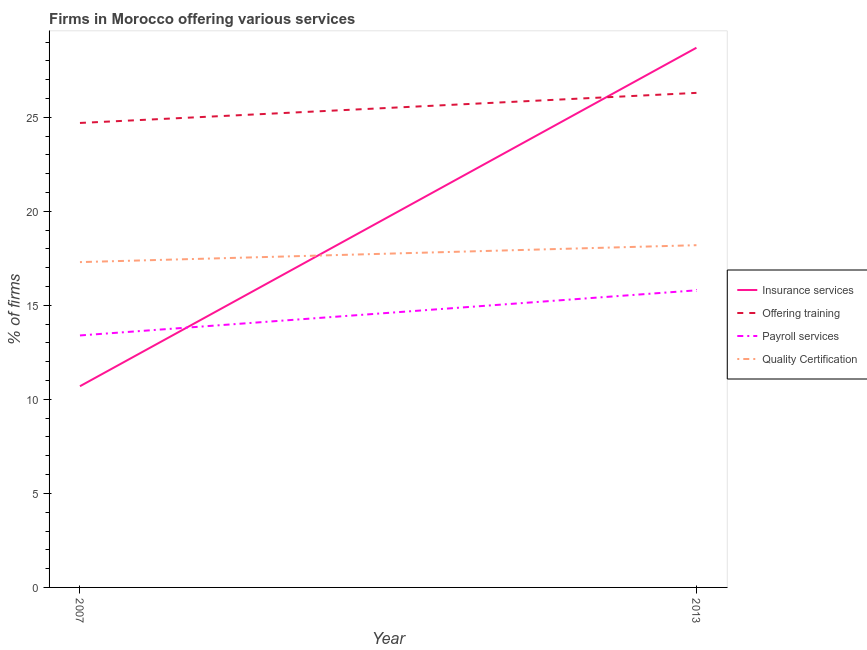How many different coloured lines are there?
Give a very brief answer. 4. What is the percentage of firms offering quality certification in 2013?
Ensure brevity in your answer.  18.2. Across all years, what is the maximum percentage of firms offering training?
Offer a very short reply. 26.3. In which year was the percentage of firms offering insurance services maximum?
Provide a succinct answer. 2013. What is the total percentage of firms offering payroll services in the graph?
Provide a short and direct response. 29.2. What is the difference between the percentage of firms offering payroll services in 2007 and the percentage of firms offering quality certification in 2013?
Make the answer very short. -4.8. What is the average percentage of firms offering insurance services per year?
Make the answer very short. 19.7. In the year 2013, what is the difference between the percentage of firms offering quality certification and percentage of firms offering training?
Your response must be concise. -8.1. What is the ratio of the percentage of firms offering payroll services in 2007 to that in 2013?
Ensure brevity in your answer.  0.85. Is the percentage of firms offering training in 2007 less than that in 2013?
Offer a terse response. Yes. In how many years, is the percentage of firms offering quality certification greater than the average percentage of firms offering quality certification taken over all years?
Provide a short and direct response. 1. Does the percentage of firms offering training monotonically increase over the years?
Your answer should be compact. Yes. Is the percentage of firms offering insurance services strictly greater than the percentage of firms offering quality certification over the years?
Keep it short and to the point. No. Is the percentage of firms offering training strictly less than the percentage of firms offering insurance services over the years?
Provide a succinct answer. No. How many lines are there?
Provide a succinct answer. 4. How many years are there in the graph?
Keep it short and to the point. 2. What is the difference between two consecutive major ticks on the Y-axis?
Ensure brevity in your answer.  5. What is the title of the graph?
Offer a very short reply. Firms in Morocco offering various services . What is the label or title of the X-axis?
Give a very brief answer. Year. What is the label or title of the Y-axis?
Offer a terse response. % of firms. What is the % of firms in Offering training in 2007?
Offer a terse response. 24.7. What is the % of firms in Payroll services in 2007?
Your response must be concise. 13.4. What is the % of firms of Insurance services in 2013?
Ensure brevity in your answer.  28.7. What is the % of firms in Offering training in 2013?
Your response must be concise. 26.3. What is the % of firms of Payroll services in 2013?
Keep it short and to the point. 15.8. What is the % of firms of Quality Certification in 2013?
Your answer should be compact. 18.2. Across all years, what is the maximum % of firms in Insurance services?
Ensure brevity in your answer.  28.7. Across all years, what is the maximum % of firms in Offering training?
Make the answer very short. 26.3. Across all years, what is the minimum % of firms in Insurance services?
Keep it short and to the point. 10.7. Across all years, what is the minimum % of firms in Offering training?
Your answer should be very brief. 24.7. Across all years, what is the minimum % of firms in Payroll services?
Keep it short and to the point. 13.4. Across all years, what is the minimum % of firms of Quality Certification?
Keep it short and to the point. 17.3. What is the total % of firms in Insurance services in the graph?
Keep it short and to the point. 39.4. What is the total % of firms in Payroll services in the graph?
Provide a short and direct response. 29.2. What is the total % of firms of Quality Certification in the graph?
Make the answer very short. 35.5. What is the difference between the % of firms of Payroll services in 2007 and that in 2013?
Ensure brevity in your answer.  -2.4. What is the difference between the % of firms of Insurance services in 2007 and the % of firms of Offering training in 2013?
Provide a short and direct response. -15.6. What is the difference between the % of firms of Insurance services in 2007 and the % of firms of Payroll services in 2013?
Keep it short and to the point. -5.1. What is the difference between the % of firms in Offering training in 2007 and the % of firms in Payroll services in 2013?
Make the answer very short. 8.9. What is the difference between the % of firms of Offering training in 2007 and the % of firms of Quality Certification in 2013?
Make the answer very short. 6.5. What is the difference between the % of firms of Payroll services in 2007 and the % of firms of Quality Certification in 2013?
Ensure brevity in your answer.  -4.8. What is the average % of firms in Insurance services per year?
Provide a short and direct response. 19.7. What is the average % of firms in Quality Certification per year?
Your response must be concise. 17.75. In the year 2007, what is the difference between the % of firms in Insurance services and % of firms in Offering training?
Make the answer very short. -14. In the year 2007, what is the difference between the % of firms of Insurance services and % of firms of Payroll services?
Your response must be concise. -2.7. In the year 2007, what is the difference between the % of firms of Insurance services and % of firms of Quality Certification?
Provide a succinct answer. -6.6. In the year 2013, what is the difference between the % of firms in Insurance services and % of firms in Quality Certification?
Provide a succinct answer. 10.5. In the year 2013, what is the difference between the % of firms in Offering training and % of firms in Quality Certification?
Make the answer very short. 8.1. What is the ratio of the % of firms in Insurance services in 2007 to that in 2013?
Ensure brevity in your answer.  0.37. What is the ratio of the % of firms of Offering training in 2007 to that in 2013?
Make the answer very short. 0.94. What is the ratio of the % of firms of Payroll services in 2007 to that in 2013?
Your response must be concise. 0.85. What is the ratio of the % of firms of Quality Certification in 2007 to that in 2013?
Provide a succinct answer. 0.95. What is the difference between the highest and the second highest % of firms of Insurance services?
Provide a short and direct response. 18. What is the difference between the highest and the second highest % of firms of Offering training?
Your answer should be very brief. 1.6. What is the difference between the highest and the second highest % of firms of Payroll services?
Offer a very short reply. 2.4. What is the difference between the highest and the second highest % of firms in Quality Certification?
Make the answer very short. 0.9. What is the difference between the highest and the lowest % of firms of Payroll services?
Your answer should be compact. 2.4. What is the difference between the highest and the lowest % of firms in Quality Certification?
Give a very brief answer. 0.9. 